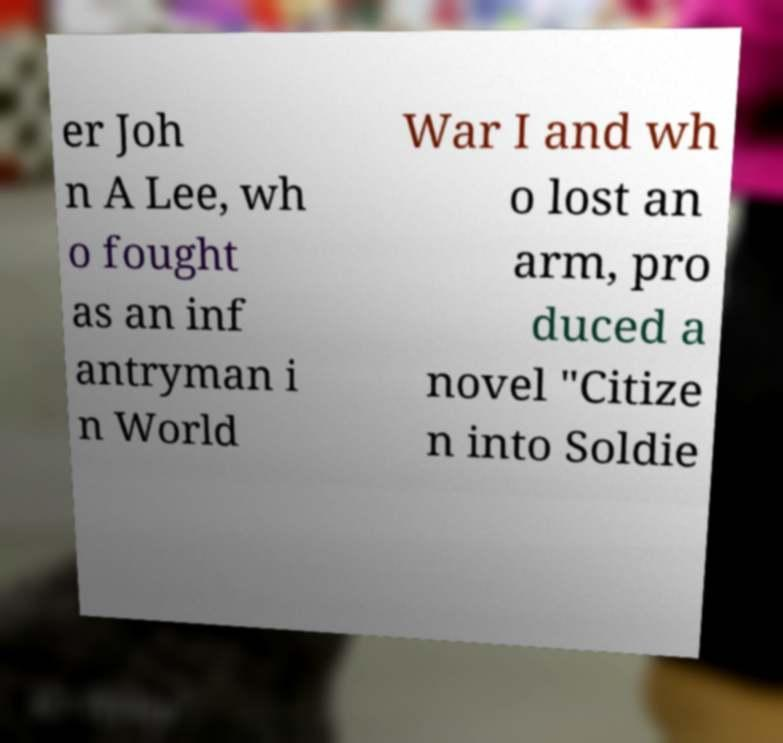Could you assist in decoding the text presented in this image and type it out clearly? er Joh n A Lee, wh o fought as an inf antryman i n World War I and wh o lost an arm, pro duced a novel "Citize n into Soldie 